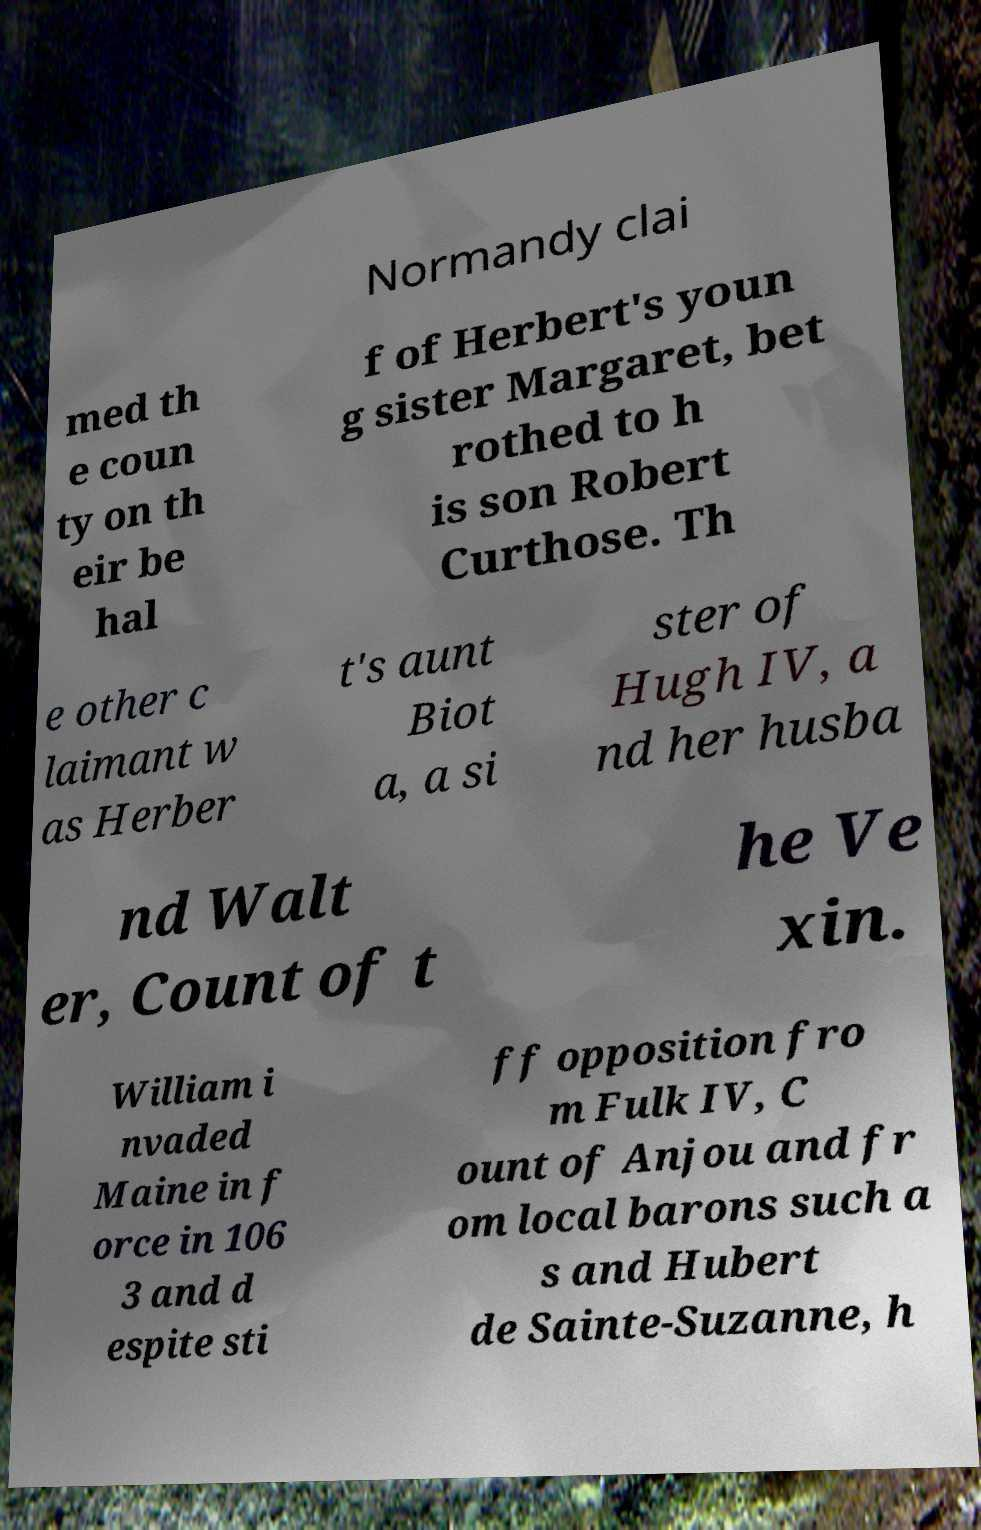There's text embedded in this image that I need extracted. Can you transcribe it verbatim? Normandy clai med th e coun ty on th eir be hal f of Herbert's youn g sister Margaret, bet rothed to h is son Robert Curthose. Th e other c laimant w as Herber t's aunt Biot a, a si ster of Hugh IV, a nd her husba nd Walt er, Count of t he Ve xin. William i nvaded Maine in f orce in 106 3 and d espite sti ff opposition fro m Fulk IV, C ount of Anjou and fr om local barons such a s and Hubert de Sainte-Suzanne, h 